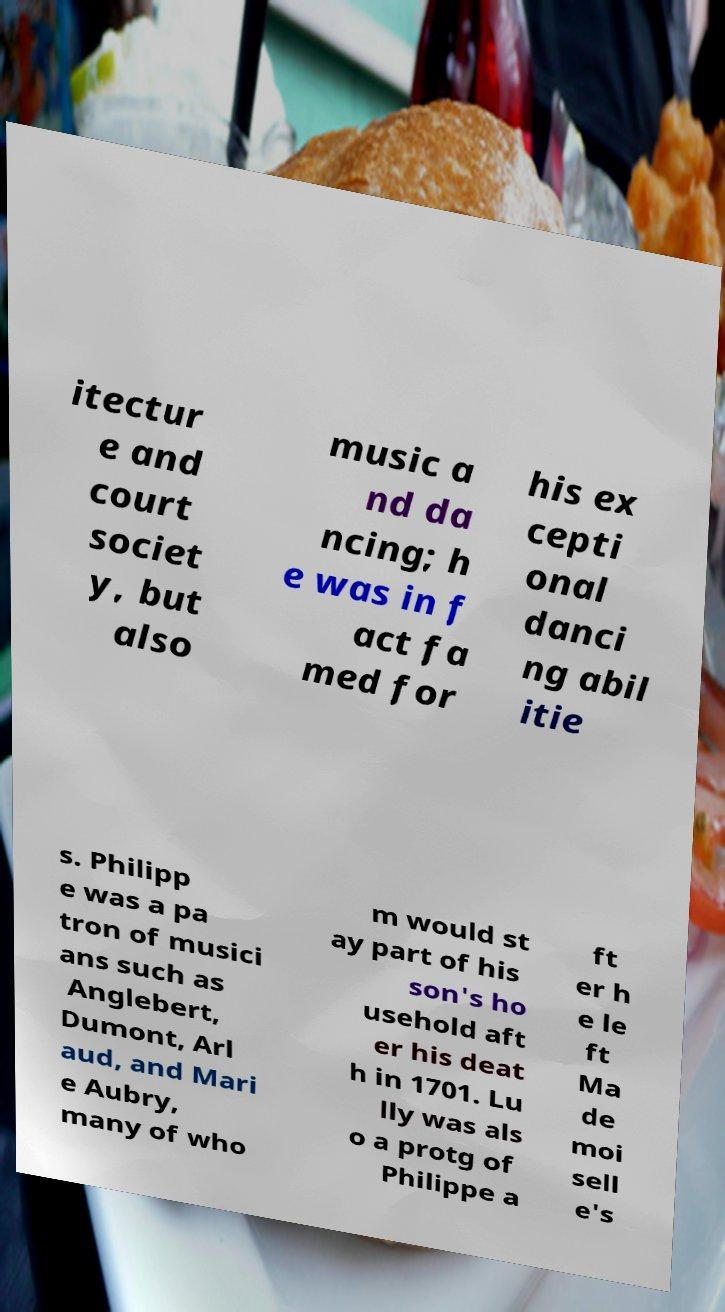I need the written content from this picture converted into text. Can you do that? itectur e and court societ y, but also music a nd da ncing; h e was in f act fa med for his ex cepti onal danci ng abil itie s. Philipp e was a pa tron of musici ans such as Anglebert, Dumont, Arl aud, and Mari e Aubry, many of who m would st ay part of his son's ho usehold aft er his deat h in 1701. Lu lly was als o a protg of Philippe a ft er h e le ft Ma de moi sell e's 